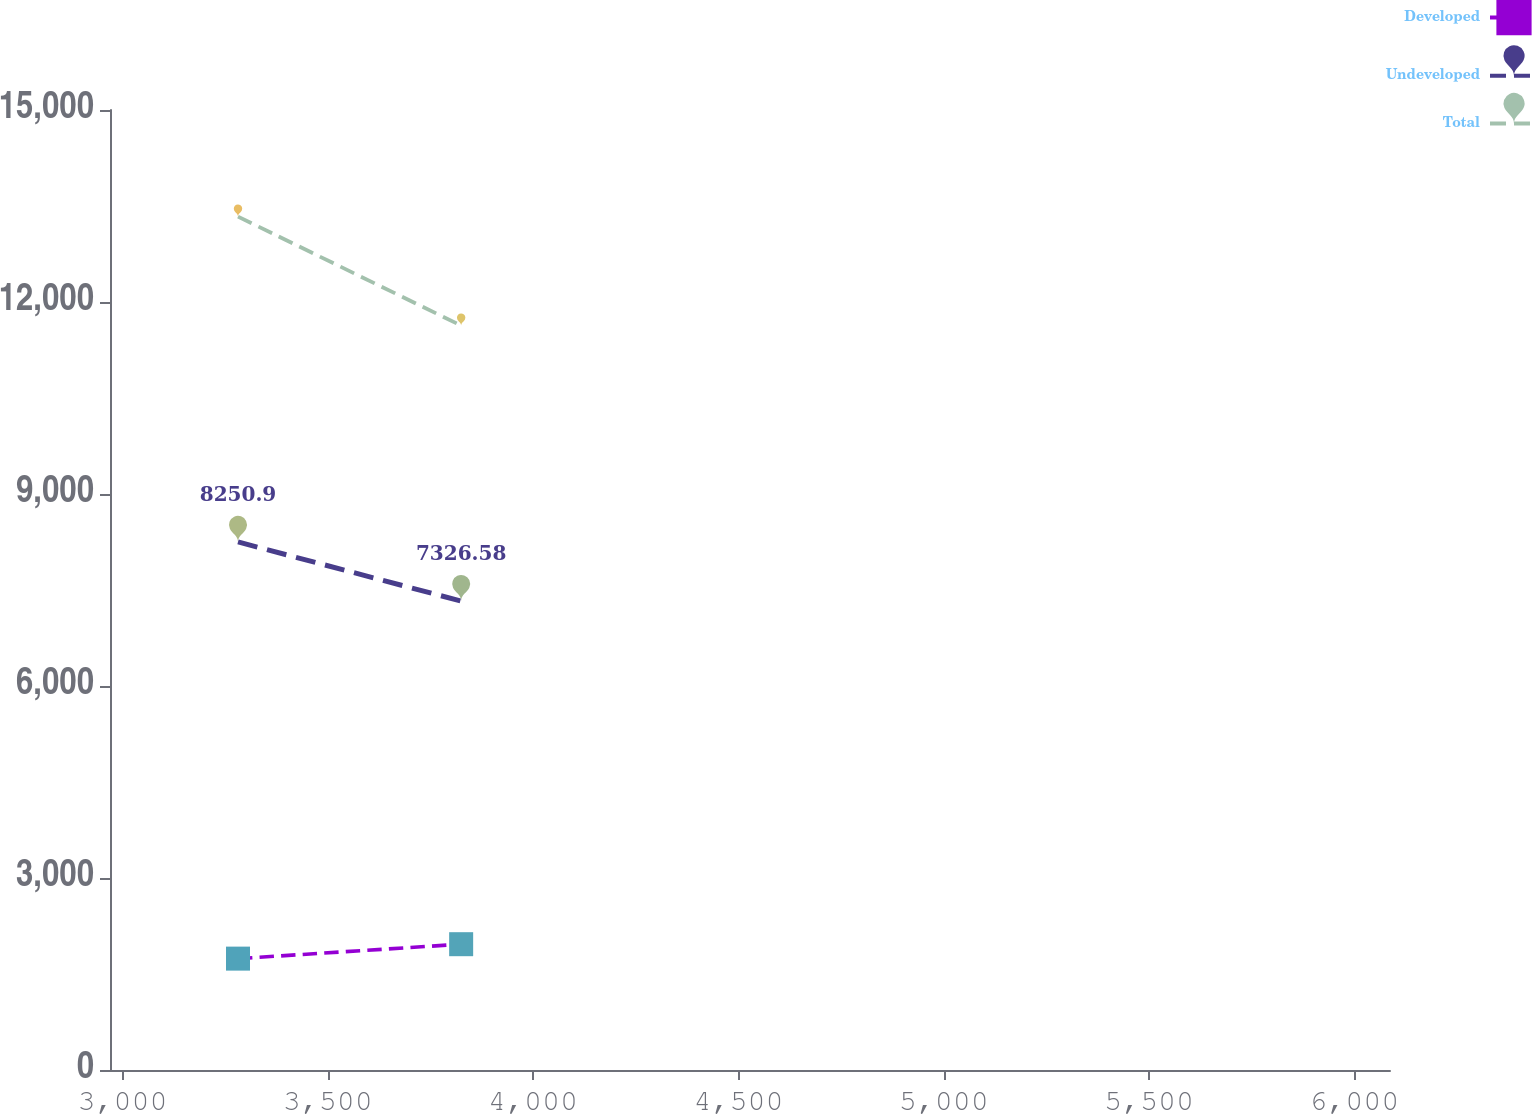<chart> <loc_0><loc_0><loc_500><loc_500><line_chart><ecel><fcel>Developed<fcel>Undeveloped<fcel>Total<nl><fcel>3281.29<fcel>1740.29<fcel>8250.9<fcel>13333.5<nl><fcel>3824.76<fcel>1965.72<fcel>7326.58<fcel>11631.3<nl><fcel>6398.55<fcel>3994.59<fcel>16569.8<fcel>23212.6<nl></chart> 